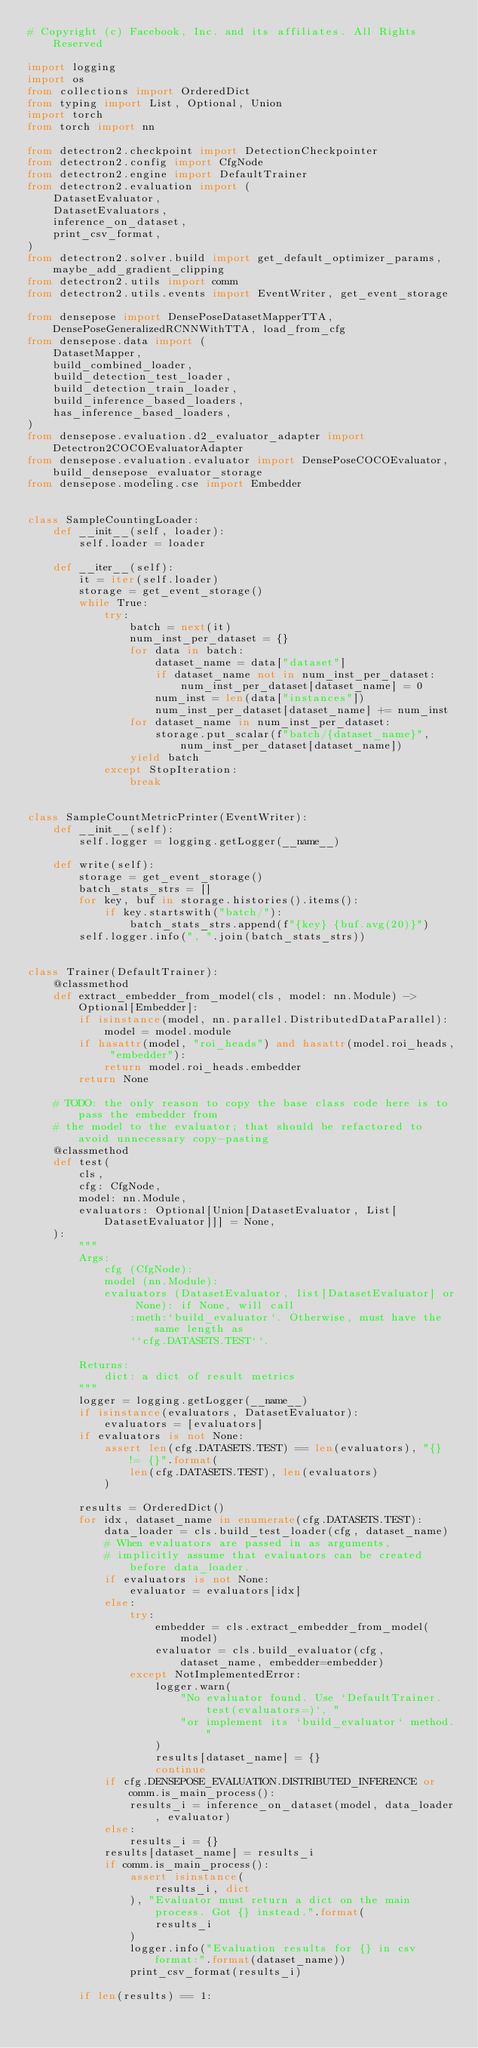Convert code to text. <code><loc_0><loc_0><loc_500><loc_500><_Python_># Copyright (c) Facebook, Inc. and its affiliates. All Rights Reserved

import logging
import os
from collections import OrderedDict
from typing import List, Optional, Union
import torch
from torch import nn

from detectron2.checkpoint import DetectionCheckpointer
from detectron2.config import CfgNode
from detectron2.engine import DefaultTrainer
from detectron2.evaluation import (
    DatasetEvaluator,
    DatasetEvaluators,
    inference_on_dataset,
    print_csv_format,
)
from detectron2.solver.build import get_default_optimizer_params, maybe_add_gradient_clipping
from detectron2.utils import comm
from detectron2.utils.events import EventWriter, get_event_storage

from densepose import DensePoseDatasetMapperTTA, DensePoseGeneralizedRCNNWithTTA, load_from_cfg
from densepose.data import (
    DatasetMapper,
    build_combined_loader,
    build_detection_test_loader,
    build_detection_train_loader,
    build_inference_based_loaders,
    has_inference_based_loaders,
)
from densepose.evaluation.d2_evaluator_adapter import Detectron2COCOEvaluatorAdapter
from densepose.evaluation.evaluator import DensePoseCOCOEvaluator, build_densepose_evaluator_storage
from densepose.modeling.cse import Embedder


class SampleCountingLoader:
    def __init__(self, loader):
        self.loader = loader

    def __iter__(self):
        it = iter(self.loader)
        storage = get_event_storage()
        while True:
            try:
                batch = next(it)
                num_inst_per_dataset = {}
                for data in batch:
                    dataset_name = data["dataset"]
                    if dataset_name not in num_inst_per_dataset:
                        num_inst_per_dataset[dataset_name] = 0
                    num_inst = len(data["instances"])
                    num_inst_per_dataset[dataset_name] += num_inst
                for dataset_name in num_inst_per_dataset:
                    storage.put_scalar(f"batch/{dataset_name}", num_inst_per_dataset[dataset_name])
                yield batch
            except StopIteration:
                break


class SampleCountMetricPrinter(EventWriter):
    def __init__(self):
        self.logger = logging.getLogger(__name__)

    def write(self):
        storage = get_event_storage()
        batch_stats_strs = []
        for key, buf in storage.histories().items():
            if key.startswith("batch/"):
                batch_stats_strs.append(f"{key} {buf.avg(20)}")
        self.logger.info(", ".join(batch_stats_strs))


class Trainer(DefaultTrainer):
    @classmethod
    def extract_embedder_from_model(cls, model: nn.Module) -> Optional[Embedder]:
        if isinstance(model, nn.parallel.DistributedDataParallel):
            model = model.module
        if hasattr(model, "roi_heads") and hasattr(model.roi_heads, "embedder"):
            return model.roi_heads.embedder
        return None

    # TODO: the only reason to copy the base class code here is to pass the embedder from
    # the model to the evaluator; that should be refactored to avoid unnecessary copy-pasting
    @classmethod
    def test(
        cls,
        cfg: CfgNode,
        model: nn.Module,
        evaluators: Optional[Union[DatasetEvaluator, List[DatasetEvaluator]]] = None,
    ):
        """
        Args:
            cfg (CfgNode):
            model (nn.Module):
            evaluators (DatasetEvaluator, list[DatasetEvaluator] or None): if None, will call
                :meth:`build_evaluator`. Otherwise, must have the same length as
                ``cfg.DATASETS.TEST``.

        Returns:
            dict: a dict of result metrics
        """
        logger = logging.getLogger(__name__)
        if isinstance(evaluators, DatasetEvaluator):
            evaluators = [evaluators]
        if evaluators is not None:
            assert len(cfg.DATASETS.TEST) == len(evaluators), "{} != {}".format(
                len(cfg.DATASETS.TEST), len(evaluators)
            )

        results = OrderedDict()
        for idx, dataset_name in enumerate(cfg.DATASETS.TEST):
            data_loader = cls.build_test_loader(cfg, dataset_name)
            # When evaluators are passed in as arguments,
            # implicitly assume that evaluators can be created before data_loader.
            if evaluators is not None:
                evaluator = evaluators[idx]
            else:
                try:
                    embedder = cls.extract_embedder_from_model(model)
                    evaluator = cls.build_evaluator(cfg, dataset_name, embedder=embedder)
                except NotImplementedError:
                    logger.warn(
                        "No evaluator found. Use `DefaultTrainer.test(evaluators=)`, "
                        "or implement its `build_evaluator` method."
                    )
                    results[dataset_name] = {}
                    continue
            if cfg.DENSEPOSE_EVALUATION.DISTRIBUTED_INFERENCE or comm.is_main_process():
                results_i = inference_on_dataset(model, data_loader, evaluator)
            else:
                results_i = {}
            results[dataset_name] = results_i
            if comm.is_main_process():
                assert isinstance(
                    results_i, dict
                ), "Evaluator must return a dict on the main process. Got {} instead.".format(
                    results_i
                )
                logger.info("Evaluation results for {} in csv format:".format(dataset_name))
                print_csv_format(results_i)

        if len(results) == 1:</code> 